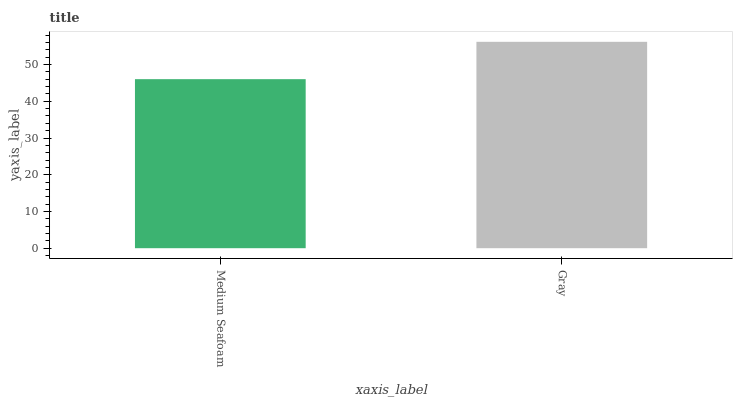Is Medium Seafoam the minimum?
Answer yes or no. Yes. Is Gray the maximum?
Answer yes or no. Yes. Is Gray the minimum?
Answer yes or no. No. Is Gray greater than Medium Seafoam?
Answer yes or no. Yes. Is Medium Seafoam less than Gray?
Answer yes or no. Yes. Is Medium Seafoam greater than Gray?
Answer yes or no. No. Is Gray less than Medium Seafoam?
Answer yes or no. No. Is Gray the high median?
Answer yes or no. Yes. Is Medium Seafoam the low median?
Answer yes or no. Yes. Is Medium Seafoam the high median?
Answer yes or no. No. Is Gray the low median?
Answer yes or no. No. 